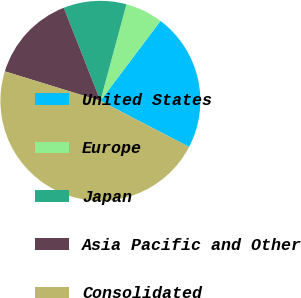Convert chart. <chart><loc_0><loc_0><loc_500><loc_500><pie_chart><fcel>United States<fcel>Europe<fcel>Japan<fcel>Asia Pacific and Other<fcel>Consolidated<nl><fcel>22.38%<fcel>6.06%<fcel>10.17%<fcel>14.27%<fcel>47.12%<nl></chart> 